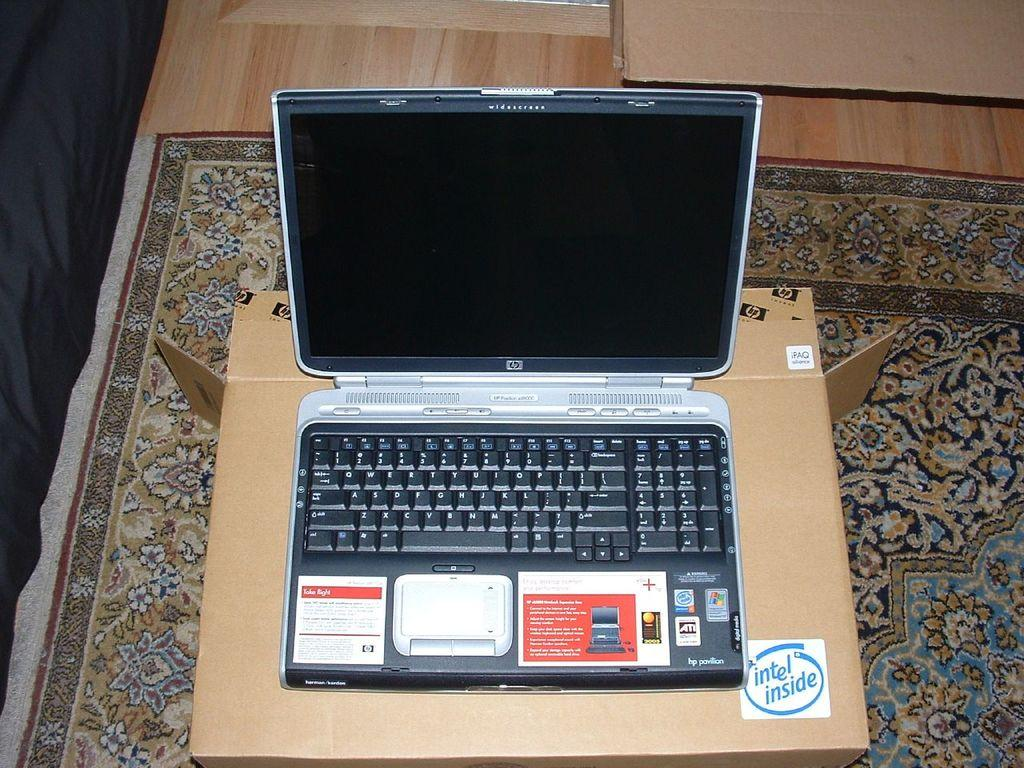<image>
Share a concise interpretation of the image provided. an open laptop with intel inside written to the bottom right of the desk it is sitting on 